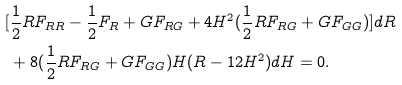Convert formula to latex. <formula><loc_0><loc_0><loc_500><loc_500>[ & \frac { 1 } { 2 } R F _ { R R } - \frac { 1 } { 2 } F _ { R } + G F _ { R G } + 4 H ^ { 2 } ( \frac { 1 } { 2 } R F _ { R G } + G F _ { G G } ) ] d R \\ & + 8 ( \frac { 1 } { 2 } R F _ { R G } + G F _ { G G } ) H ( R - 1 2 H ^ { 2 } ) d H = 0 .</formula> 